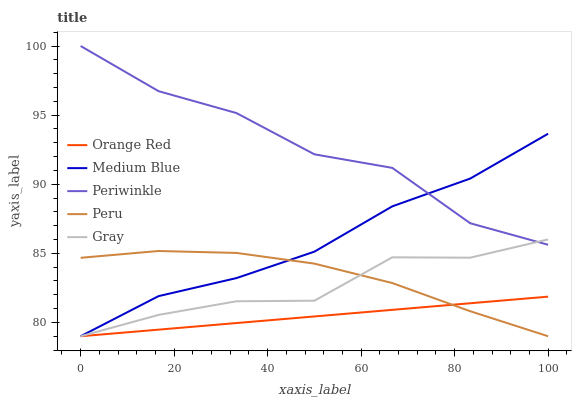Does Orange Red have the minimum area under the curve?
Answer yes or no. Yes. Does Periwinkle have the maximum area under the curve?
Answer yes or no. Yes. Does Medium Blue have the minimum area under the curve?
Answer yes or no. No. Does Medium Blue have the maximum area under the curve?
Answer yes or no. No. Is Orange Red the smoothest?
Answer yes or no. Yes. Is Periwinkle the roughest?
Answer yes or no. Yes. Is Medium Blue the smoothest?
Answer yes or no. No. Is Medium Blue the roughest?
Answer yes or no. No. Does Periwinkle have the highest value?
Answer yes or no. Yes. Does Medium Blue have the highest value?
Answer yes or no. No. Is Orange Red less than Periwinkle?
Answer yes or no. Yes. Is Periwinkle greater than Orange Red?
Answer yes or no. Yes. Does Medium Blue intersect Gray?
Answer yes or no. Yes. Is Medium Blue less than Gray?
Answer yes or no. No. Is Medium Blue greater than Gray?
Answer yes or no. No. Does Orange Red intersect Periwinkle?
Answer yes or no. No. 